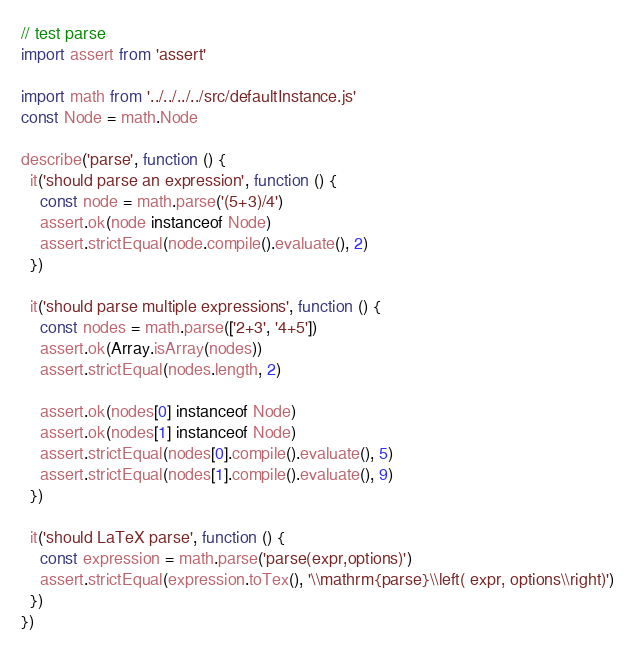<code> <loc_0><loc_0><loc_500><loc_500><_JavaScript_>// test parse
import assert from 'assert'

import math from '../../../../src/defaultInstance.js'
const Node = math.Node

describe('parse', function () {
  it('should parse an expression', function () {
    const node = math.parse('(5+3)/4')
    assert.ok(node instanceof Node)
    assert.strictEqual(node.compile().evaluate(), 2)
  })

  it('should parse multiple expressions', function () {
    const nodes = math.parse(['2+3', '4+5'])
    assert.ok(Array.isArray(nodes))
    assert.strictEqual(nodes.length, 2)

    assert.ok(nodes[0] instanceof Node)
    assert.ok(nodes[1] instanceof Node)
    assert.strictEqual(nodes[0].compile().evaluate(), 5)
    assert.strictEqual(nodes[1].compile().evaluate(), 9)
  })

  it('should LaTeX parse', function () {
    const expression = math.parse('parse(expr,options)')
    assert.strictEqual(expression.toTex(), '\\mathrm{parse}\\left( expr, options\\right)')
  })
})
</code> 